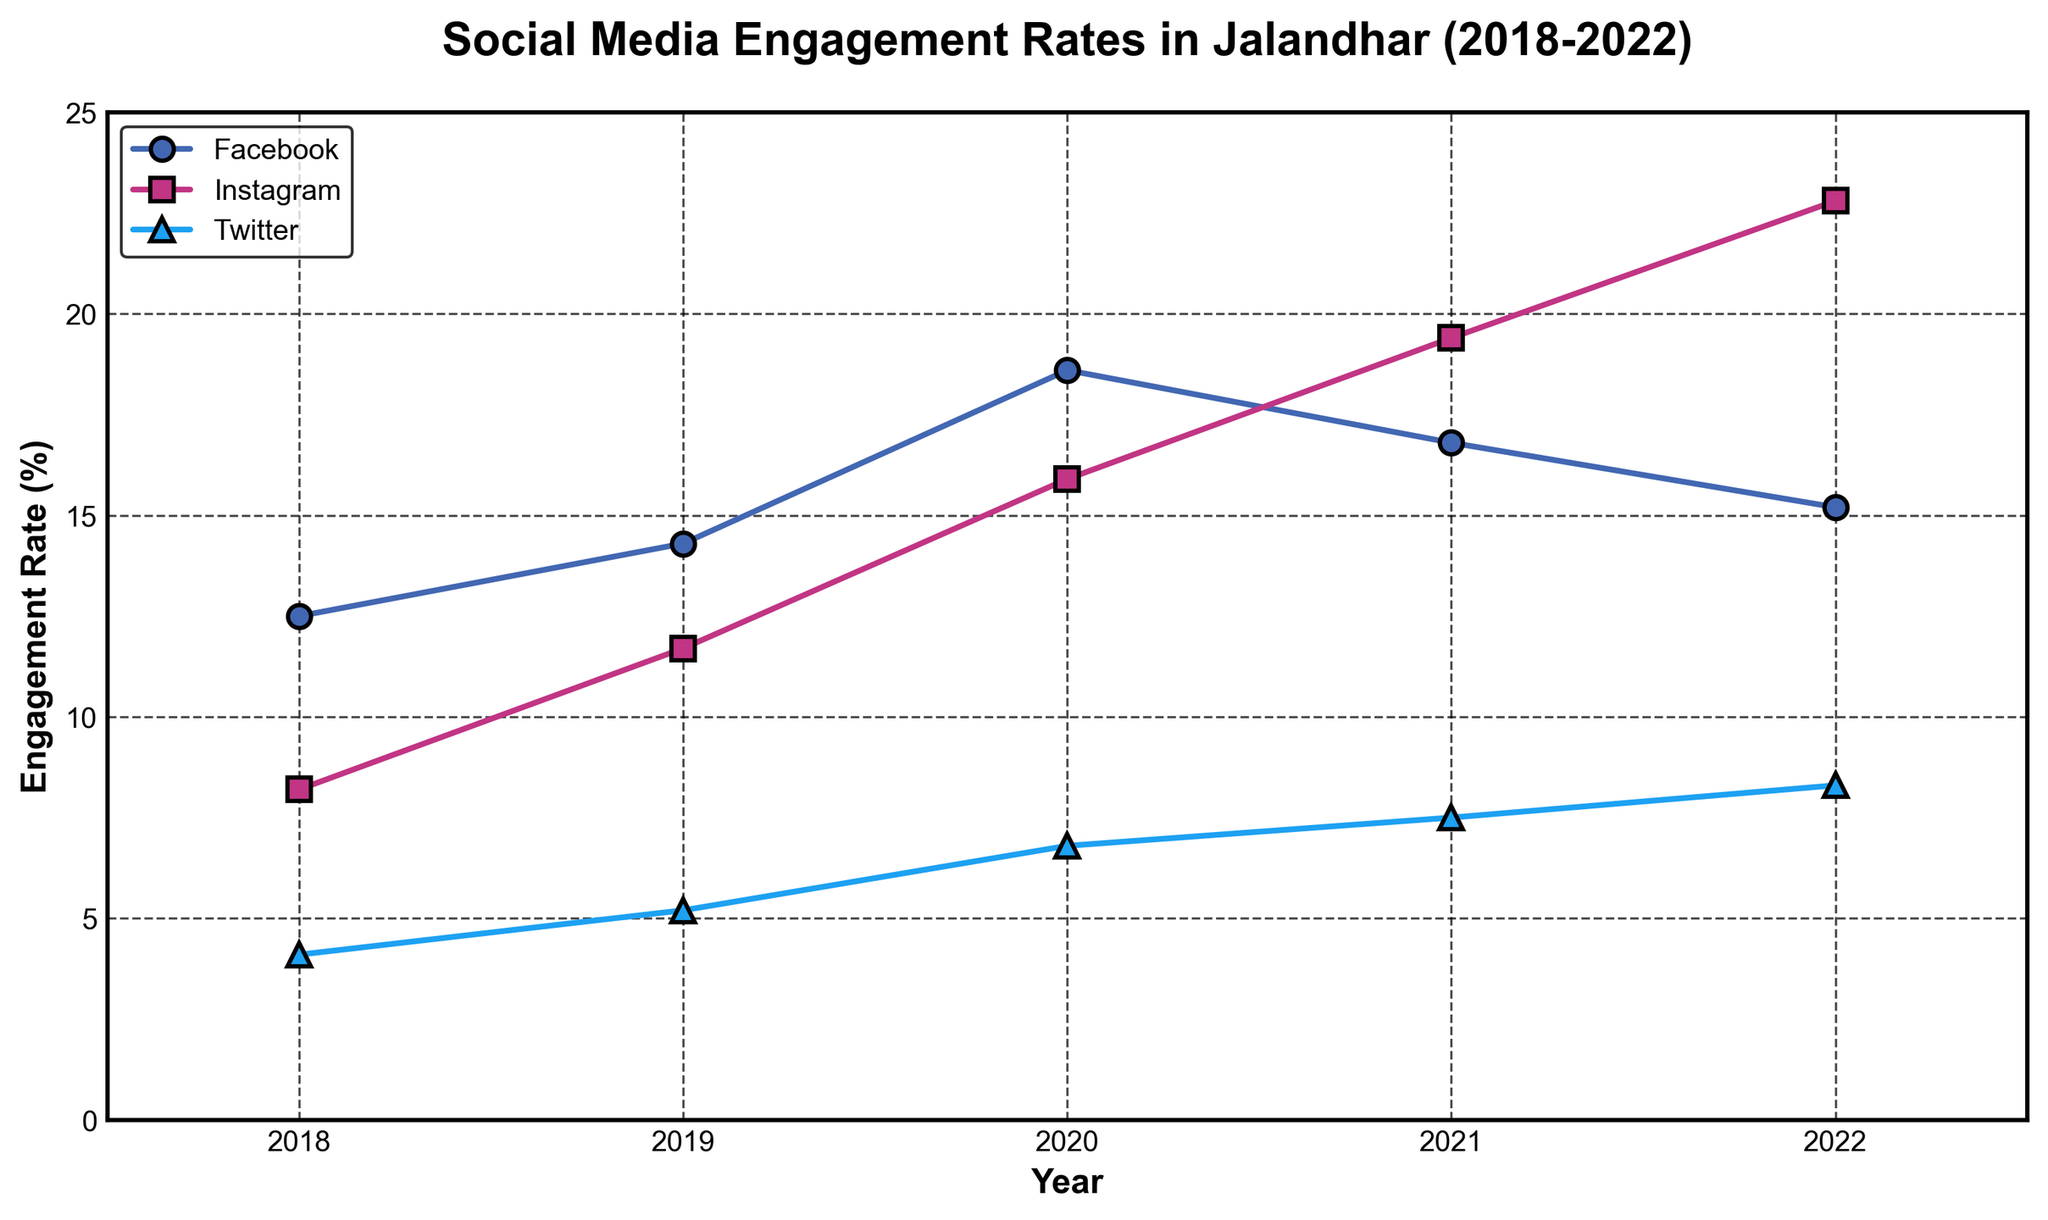How has Facebook's engagement rate changed in the past five years? The data shows the engagement rates for Facebook from 2018 to 2022. To find the change, observe the values: 12.5% in 2018, 14.3% in 2019, 18.6% in 2020, 16.8% in 2021, and 15.2% in 2022. It increased from 2018 to 2020, then slightly declined in 2021 and 2022.
Answer: Increased initially, then decreased slightly Which social media platform had the highest engagement rate in 2022? Look at the engagement rates for 2022: Facebook (15.2%), Instagram (22.8%), and Twitter (8.3%). The highest rate is 22.8% for Instagram.
Answer: Instagram What is the total engagement rate for Twitter over the five years? Sum the engagement rates for Twitter from 2018 to 2022: 4.1 + 5.2 + 6.8 + 7.5 + 8.3 = 31.9%
Answer: 31.9% In which year did Instagram surpass Facebook in engagement rates? Compare the annual engagement rates of Instagram and Facebook. Instagram surpasses Facebook in 2021, where Instagram has 19.4% and Facebook has 16.8%.
Answer: 2021 By how much did Instagram's engagement rate increase from 2018 to 2022? Subtract Instagram's engagement rate in 2018 (8.2%) from its rate in 2022 (22.8%): 22.8 - 8.2 = 14.6%
Answer: 14.6% Which platform shows a consistent increase in engagement rate over the years? Analyze the trends for each platform. Twitter shows a consistent increase: 4.1% (2018), 5.2% (2019), 6.8% (2020), 7.5% (2021), and 8.3% (2022).
Answer: Twitter What is the average engagement rate for Facebook across the five years? Sum the engagement rates for Facebook (12.5, 14.3, 18.6, 16.8, 15.2), then divide by 5. (12.5 + 14.3 + 18.6 + 16.8 + 15.2) / 5 = 15.48%
Answer: 15.48% Compare the engagement rates of Instagram and Twitter in 2020. Which one is higher and by how much? Instagram's rate in 2020 is 15.9%, and Twitter's rate is 6.8%. Subtract Twitter's rate from Instagram's: 15.9 - 6.8 = 9.1%. Instagram's rate is higher.
Answer: Instagram by 9.1% What trend can be observed in Instagram's engagement rate from 2018 to 2022? Looking at Instagram's rates: 8.2%, 11.7%, 15.9%, 19.4%, 22.8%. The engagement rate shows a consistent upward trend each year.
Answer: Consistent increase 